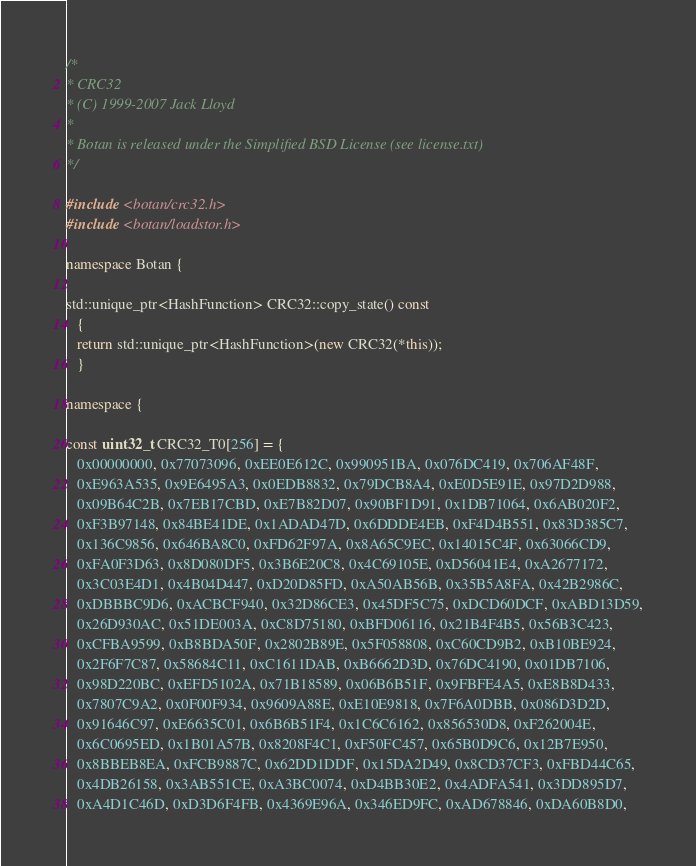<code> <loc_0><loc_0><loc_500><loc_500><_C++_>/*
* CRC32
* (C) 1999-2007 Jack Lloyd
*
* Botan is released under the Simplified BSD License (see license.txt)
*/

#include <botan/crc32.h>
#include <botan/loadstor.h>

namespace Botan {

std::unique_ptr<HashFunction> CRC32::copy_state() const
   {
   return std::unique_ptr<HashFunction>(new CRC32(*this));
   }

namespace {

const uint32_t CRC32_T0[256] = {
   0x00000000, 0x77073096, 0xEE0E612C, 0x990951BA, 0x076DC419, 0x706AF48F,
   0xE963A535, 0x9E6495A3, 0x0EDB8832, 0x79DCB8A4, 0xE0D5E91E, 0x97D2D988,
   0x09B64C2B, 0x7EB17CBD, 0xE7B82D07, 0x90BF1D91, 0x1DB71064, 0x6AB020F2,
   0xF3B97148, 0x84BE41DE, 0x1ADAD47D, 0x6DDDE4EB, 0xF4D4B551, 0x83D385C7,
   0x136C9856, 0x646BA8C0, 0xFD62F97A, 0x8A65C9EC, 0x14015C4F, 0x63066CD9,
   0xFA0F3D63, 0x8D080DF5, 0x3B6E20C8, 0x4C69105E, 0xD56041E4, 0xA2677172,
   0x3C03E4D1, 0x4B04D447, 0xD20D85FD, 0xA50AB56B, 0x35B5A8FA, 0x42B2986C,
   0xDBBBC9D6, 0xACBCF940, 0x32D86CE3, 0x45DF5C75, 0xDCD60DCF, 0xABD13D59,
   0x26D930AC, 0x51DE003A, 0xC8D75180, 0xBFD06116, 0x21B4F4B5, 0x56B3C423,
   0xCFBA9599, 0xB8BDA50F, 0x2802B89E, 0x5F058808, 0xC60CD9B2, 0xB10BE924,
   0x2F6F7C87, 0x58684C11, 0xC1611DAB, 0xB6662D3D, 0x76DC4190, 0x01DB7106,
   0x98D220BC, 0xEFD5102A, 0x71B18589, 0x06B6B51F, 0x9FBFE4A5, 0xE8B8D433,
   0x7807C9A2, 0x0F00F934, 0x9609A88E, 0xE10E9818, 0x7F6A0DBB, 0x086D3D2D,
   0x91646C97, 0xE6635C01, 0x6B6B51F4, 0x1C6C6162, 0x856530D8, 0xF262004E,
   0x6C0695ED, 0x1B01A57B, 0x8208F4C1, 0xF50FC457, 0x65B0D9C6, 0x12B7E950,
   0x8BBEB8EA, 0xFCB9887C, 0x62DD1DDF, 0x15DA2D49, 0x8CD37CF3, 0xFBD44C65,
   0x4DB26158, 0x3AB551CE, 0xA3BC0074, 0xD4BB30E2, 0x4ADFA541, 0x3DD895D7,
   0xA4D1C46D, 0xD3D6F4FB, 0x4369E96A, 0x346ED9FC, 0xAD678846, 0xDA60B8D0,</code> 